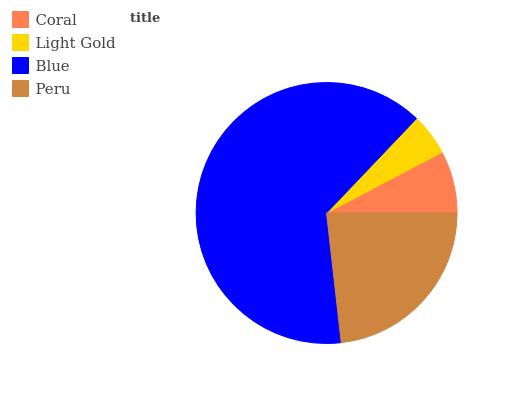Is Light Gold the minimum?
Answer yes or no. Yes. Is Blue the maximum?
Answer yes or no. Yes. Is Blue the minimum?
Answer yes or no. No. Is Light Gold the maximum?
Answer yes or no. No. Is Blue greater than Light Gold?
Answer yes or no. Yes. Is Light Gold less than Blue?
Answer yes or no. Yes. Is Light Gold greater than Blue?
Answer yes or no. No. Is Blue less than Light Gold?
Answer yes or no. No. Is Peru the high median?
Answer yes or no. Yes. Is Coral the low median?
Answer yes or no. Yes. Is Light Gold the high median?
Answer yes or no. No. Is Blue the low median?
Answer yes or no. No. 